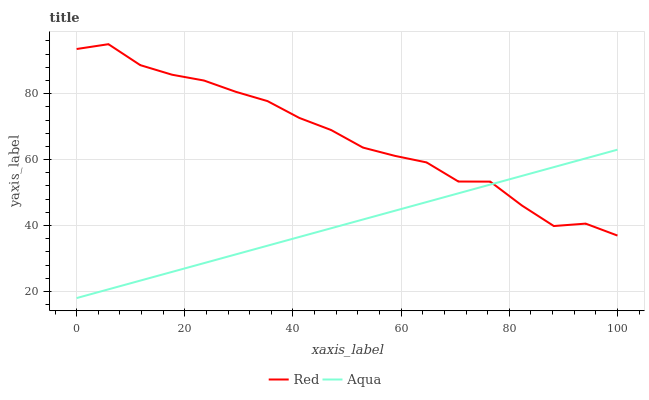Does Aqua have the minimum area under the curve?
Answer yes or no. Yes. Does Red have the maximum area under the curve?
Answer yes or no. Yes. Does Red have the minimum area under the curve?
Answer yes or no. No. Is Aqua the smoothest?
Answer yes or no. Yes. Is Red the roughest?
Answer yes or no. Yes. Is Red the smoothest?
Answer yes or no. No. Does Aqua have the lowest value?
Answer yes or no. Yes. Does Red have the lowest value?
Answer yes or no. No. Does Red have the highest value?
Answer yes or no. Yes. Does Red intersect Aqua?
Answer yes or no. Yes. Is Red less than Aqua?
Answer yes or no. No. Is Red greater than Aqua?
Answer yes or no. No. 